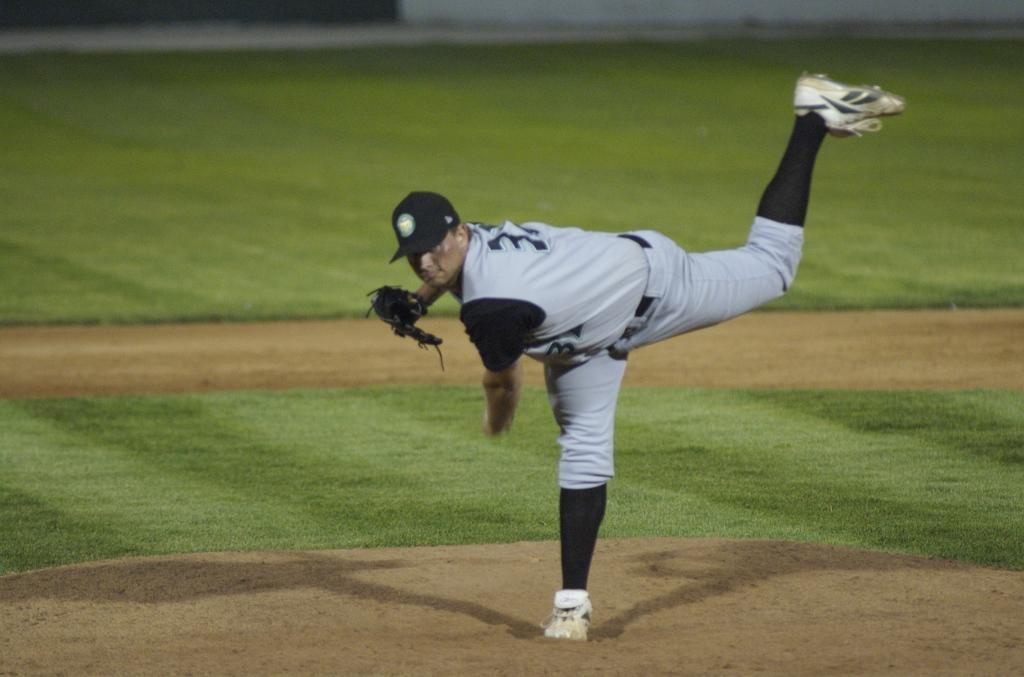What is the main subject of the image? The main subject of the image is a man. Where is the man located in the image? The man is in the middle of the image. What can be seen in the background of the image? There is a playing ground in the background of the image. What type of badge is the man wearing in the image? There is no badge visible on the man in the image. How many beads are present on the man's necklace in the image? There is no necklace or beads present on the man in the image. 